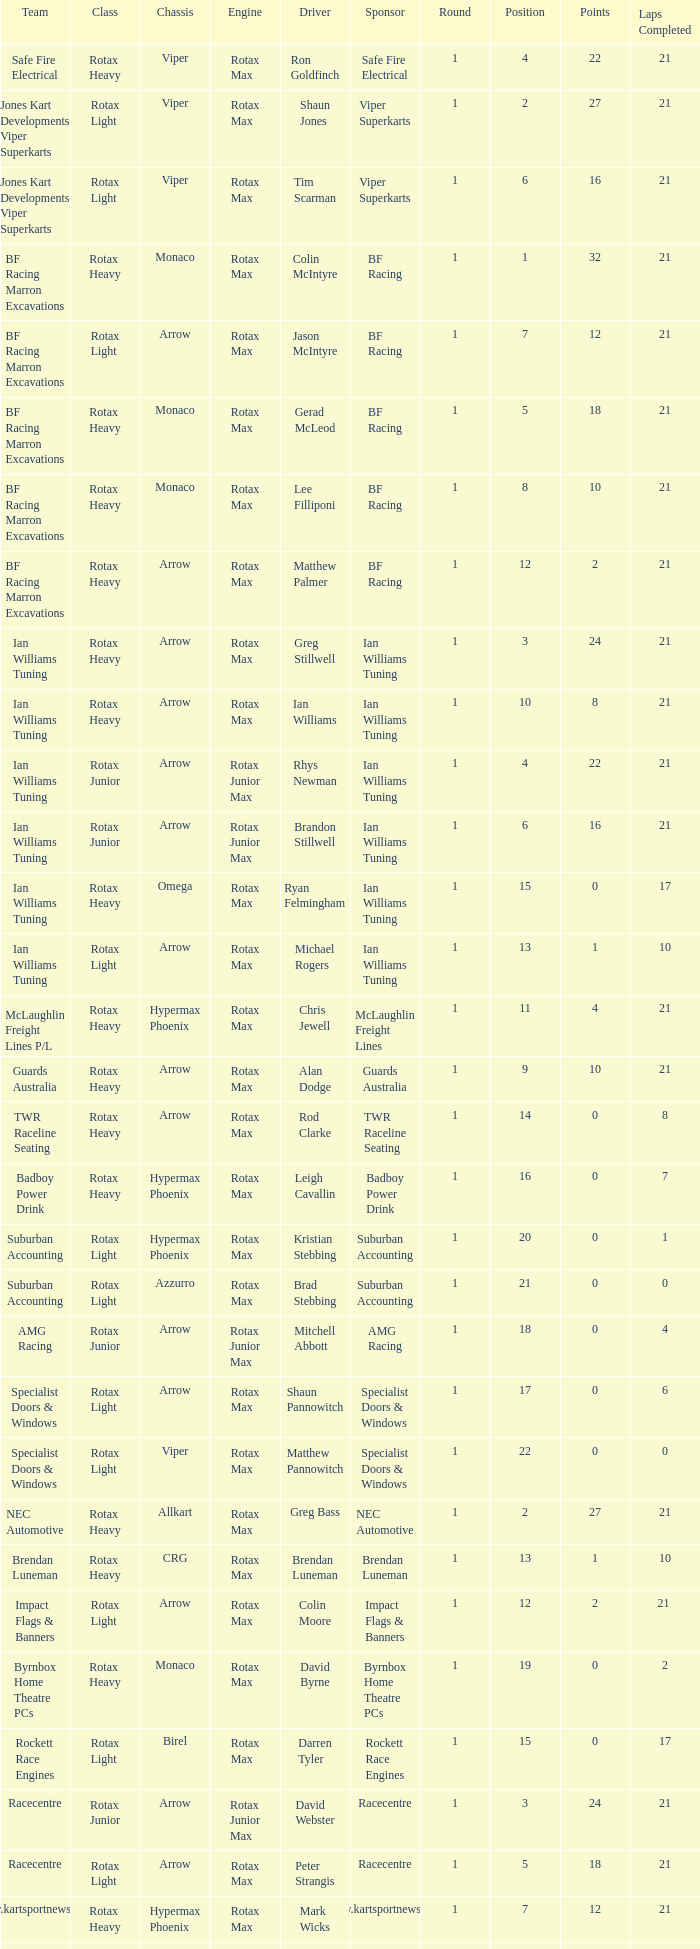Driver Shaun Jones with a viper as a chassis is in what class? Rotax Light. 